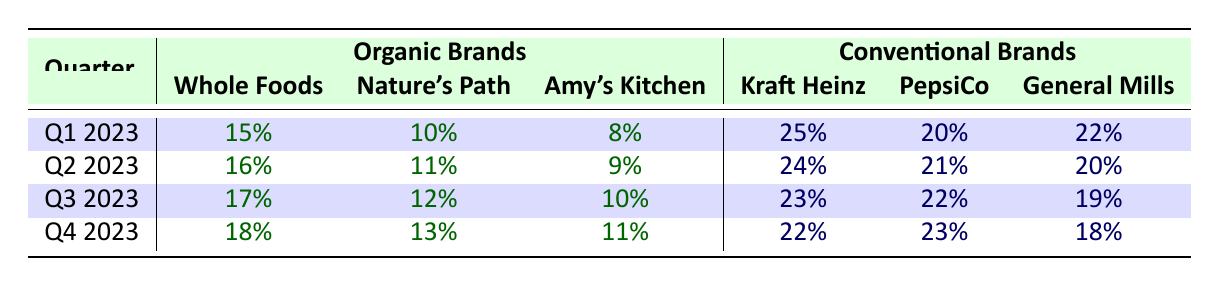What was the market share of Whole Foods Market in Q3 2023? According to the table, in Q3 2023, the market share of Whole Foods Market is listed as 17%.
Answer: 17% Which brand had the highest market share in Q1 2023? The highest market share in Q1 2023 can be found by comparing the top values across all brands. Kraft Heinz has the highest value at 25%.
Answer: Kraft Heinz What is the total market share for organic brands in Q4 2023? To find the total, we sum the market shares of organic brands in Q4 2023: 18% (Whole Foods Market) + 13% (Nature's Path) + 11% (Amy's Kitchen) = 42%.
Answer: 42% Is Nature's Path market share consistently increasing throughout the quarters? By examining the values for Nature's Path in each quarter (10%, 11%, 12%, 13%), we see that the numbers are increasing from Q1 to Q4, indicating a consistent upward trend.
Answer: Yes What is the difference in market share for General Mills between Q1 2023 and Q4 2023? To find the difference, we compare the values for General Mills: in Q1 2023, it's 22% and in Q4 2023, it's 18%. The difference is 22% - 18% = 4%.
Answer: 4% What was the average market share of conventional brands in Q2 2023? The average is calculated by finding the sum of the individual market shares and dividing by the number of brands. The values are 24% (Kraft Heinz), 21% (PepsiCo), and 20% (General Mills). So, average = (24 + 21 + 20) / 3 = 21.67%, rounded down to 21%.
Answer: 21% Did the overall market share of organic brands surpass that of conventional brands in any quarter? By examining and comparing the total percentages for organic and conventional brands across the quarters, it's clear that organic brands do not exceed conventional brands in any quarter.
Answer: No Which brand showed the highest growth rate over the four quarters? To determine growth rate, we analyze the percentage increase of each brand over the four quarters. Whole Foods Market’s percentages are as follows: 15% to 18%, a growth of 3%. Nature's Path from 10% to 13% grows by 3%. Amy's Kitchen increases from 8% to 11%, also a growth of 3%. All three brands have equal growth. However, this is the maximum among organic.
Answer: Whole Foods, Nature's Path, Amy's Kitchen (all equal growth of 3%) 